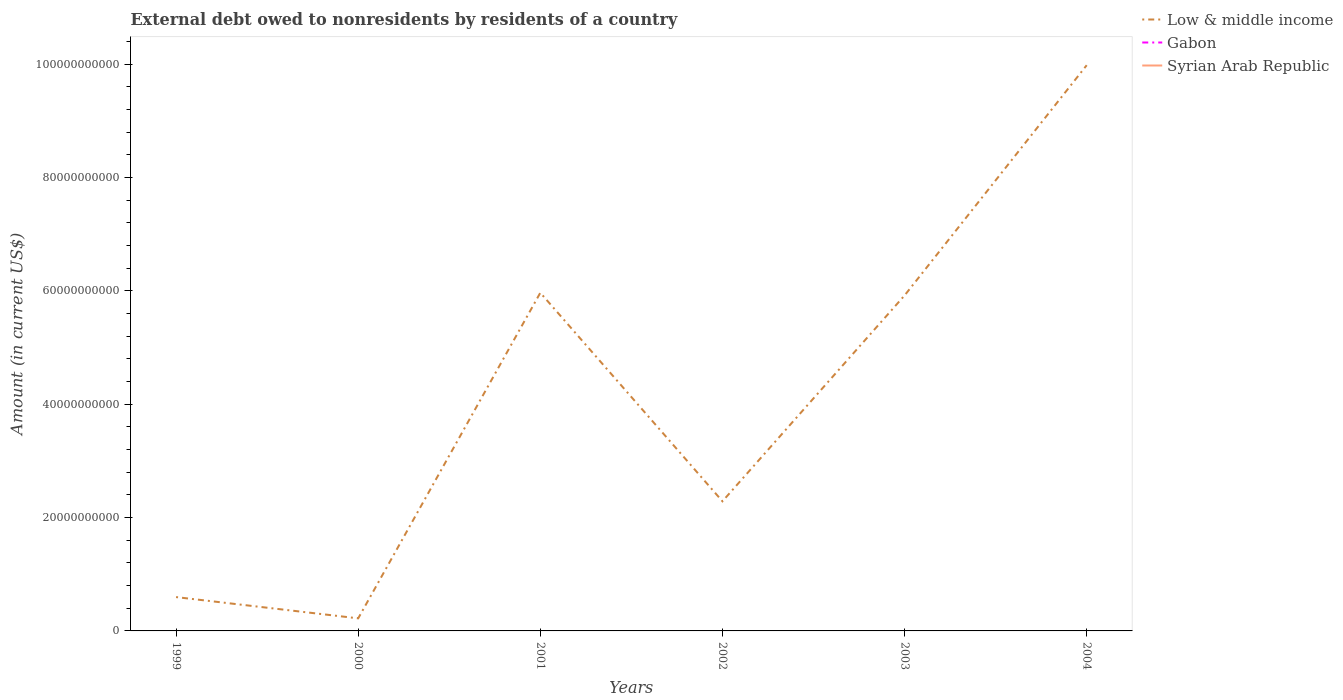Does the line corresponding to Low & middle income intersect with the line corresponding to Syrian Arab Republic?
Provide a short and direct response. No. Across all years, what is the maximum external debt owed by residents in Gabon?
Provide a succinct answer. 0. What is the total external debt owed by residents in Low & middle income in the graph?
Give a very brief answer. 3.75e+09. What is the difference between the highest and the second highest external debt owed by residents in Low & middle income?
Your answer should be very brief. 9.76e+1. How many lines are there?
Provide a short and direct response. 1. How many years are there in the graph?
Your response must be concise. 6. What is the difference between two consecutive major ticks on the Y-axis?
Your answer should be very brief. 2.00e+1. Are the values on the major ticks of Y-axis written in scientific E-notation?
Provide a succinct answer. No. How many legend labels are there?
Keep it short and to the point. 3. How are the legend labels stacked?
Ensure brevity in your answer.  Vertical. What is the title of the graph?
Offer a terse response. External debt owed to nonresidents by residents of a country. What is the Amount (in current US$) of Low & middle income in 1999?
Offer a terse response. 5.97e+09. What is the Amount (in current US$) of Gabon in 1999?
Offer a terse response. 0. What is the Amount (in current US$) in Syrian Arab Republic in 1999?
Make the answer very short. 0. What is the Amount (in current US$) of Low & middle income in 2000?
Keep it short and to the point. 2.22e+09. What is the Amount (in current US$) in Gabon in 2000?
Provide a short and direct response. 0. What is the Amount (in current US$) of Low & middle income in 2001?
Offer a terse response. 5.97e+1. What is the Amount (in current US$) of Syrian Arab Republic in 2001?
Your answer should be very brief. 0. What is the Amount (in current US$) in Low & middle income in 2002?
Ensure brevity in your answer.  2.29e+1. What is the Amount (in current US$) of Low & middle income in 2003?
Make the answer very short. 5.92e+1. What is the Amount (in current US$) of Gabon in 2003?
Your response must be concise. 0. What is the Amount (in current US$) in Syrian Arab Republic in 2003?
Your response must be concise. 0. What is the Amount (in current US$) of Low & middle income in 2004?
Your answer should be compact. 9.98e+1. What is the Amount (in current US$) in Gabon in 2004?
Keep it short and to the point. 0. Across all years, what is the maximum Amount (in current US$) in Low & middle income?
Provide a succinct answer. 9.98e+1. Across all years, what is the minimum Amount (in current US$) in Low & middle income?
Your answer should be very brief. 2.22e+09. What is the total Amount (in current US$) of Low & middle income in the graph?
Ensure brevity in your answer.  2.50e+11. What is the total Amount (in current US$) of Syrian Arab Republic in the graph?
Offer a terse response. 0. What is the difference between the Amount (in current US$) of Low & middle income in 1999 and that in 2000?
Give a very brief answer. 3.75e+09. What is the difference between the Amount (in current US$) in Low & middle income in 1999 and that in 2001?
Offer a very short reply. -5.37e+1. What is the difference between the Amount (in current US$) of Low & middle income in 1999 and that in 2002?
Keep it short and to the point. -1.69e+1. What is the difference between the Amount (in current US$) in Low & middle income in 1999 and that in 2003?
Keep it short and to the point. -5.32e+1. What is the difference between the Amount (in current US$) of Low & middle income in 1999 and that in 2004?
Provide a succinct answer. -9.38e+1. What is the difference between the Amount (in current US$) of Low & middle income in 2000 and that in 2001?
Keep it short and to the point. -5.74e+1. What is the difference between the Amount (in current US$) of Low & middle income in 2000 and that in 2002?
Give a very brief answer. -2.06e+1. What is the difference between the Amount (in current US$) of Low & middle income in 2000 and that in 2003?
Your response must be concise. -5.70e+1. What is the difference between the Amount (in current US$) in Low & middle income in 2000 and that in 2004?
Your answer should be compact. -9.76e+1. What is the difference between the Amount (in current US$) of Low & middle income in 2001 and that in 2002?
Your answer should be very brief. 3.68e+1. What is the difference between the Amount (in current US$) in Low & middle income in 2001 and that in 2003?
Give a very brief answer. 4.75e+08. What is the difference between the Amount (in current US$) of Low & middle income in 2001 and that in 2004?
Your answer should be compact. -4.01e+1. What is the difference between the Amount (in current US$) of Low & middle income in 2002 and that in 2003?
Make the answer very short. -3.63e+1. What is the difference between the Amount (in current US$) of Low & middle income in 2002 and that in 2004?
Give a very brief answer. -7.69e+1. What is the difference between the Amount (in current US$) of Low & middle income in 2003 and that in 2004?
Your answer should be compact. -4.06e+1. What is the average Amount (in current US$) of Low & middle income per year?
Your answer should be compact. 4.16e+1. What is the average Amount (in current US$) of Gabon per year?
Your answer should be compact. 0. What is the average Amount (in current US$) of Syrian Arab Republic per year?
Offer a terse response. 0. What is the ratio of the Amount (in current US$) in Low & middle income in 1999 to that in 2000?
Keep it short and to the point. 2.69. What is the ratio of the Amount (in current US$) of Low & middle income in 1999 to that in 2001?
Offer a very short reply. 0.1. What is the ratio of the Amount (in current US$) in Low & middle income in 1999 to that in 2002?
Provide a succinct answer. 0.26. What is the ratio of the Amount (in current US$) of Low & middle income in 1999 to that in 2003?
Your answer should be very brief. 0.1. What is the ratio of the Amount (in current US$) of Low & middle income in 1999 to that in 2004?
Ensure brevity in your answer.  0.06. What is the ratio of the Amount (in current US$) of Low & middle income in 2000 to that in 2001?
Make the answer very short. 0.04. What is the ratio of the Amount (in current US$) of Low & middle income in 2000 to that in 2002?
Offer a very short reply. 0.1. What is the ratio of the Amount (in current US$) in Low & middle income in 2000 to that in 2003?
Ensure brevity in your answer.  0.04. What is the ratio of the Amount (in current US$) in Low & middle income in 2000 to that in 2004?
Your response must be concise. 0.02. What is the ratio of the Amount (in current US$) of Low & middle income in 2001 to that in 2002?
Your answer should be compact. 2.61. What is the ratio of the Amount (in current US$) in Low & middle income in 2001 to that in 2003?
Ensure brevity in your answer.  1.01. What is the ratio of the Amount (in current US$) of Low & middle income in 2001 to that in 2004?
Make the answer very short. 0.6. What is the ratio of the Amount (in current US$) in Low & middle income in 2002 to that in 2003?
Offer a terse response. 0.39. What is the ratio of the Amount (in current US$) in Low & middle income in 2002 to that in 2004?
Offer a very short reply. 0.23. What is the ratio of the Amount (in current US$) in Low & middle income in 2003 to that in 2004?
Your answer should be very brief. 0.59. What is the difference between the highest and the second highest Amount (in current US$) of Low & middle income?
Your response must be concise. 4.01e+1. What is the difference between the highest and the lowest Amount (in current US$) in Low & middle income?
Your answer should be compact. 9.76e+1. 